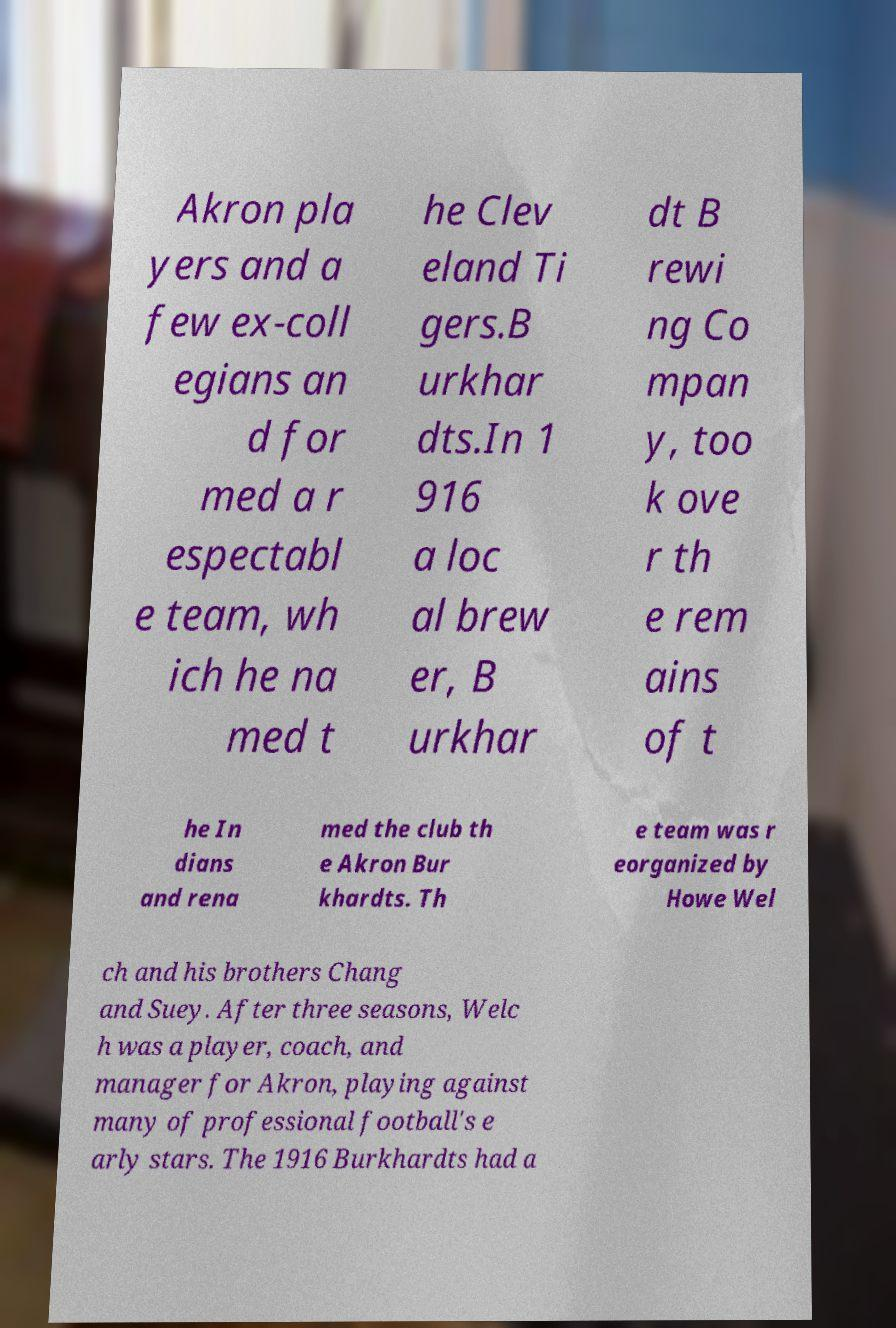Please read and relay the text visible in this image. What does it say? Akron pla yers and a few ex-coll egians an d for med a r espectabl e team, wh ich he na med t he Clev eland Ti gers.B urkhar dts.In 1 916 a loc al brew er, B urkhar dt B rewi ng Co mpan y, too k ove r th e rem ains of t he In dians and rena med the club th e Akron Bur khardts. Th e team was r eorganized by Howe Wel ch and his brothers Chang and Suey. After three seasons, Welc h was a player, coach, and manager for Akron, playing against many of professional football's e arly stars. The 1916 Burkhardts had a 